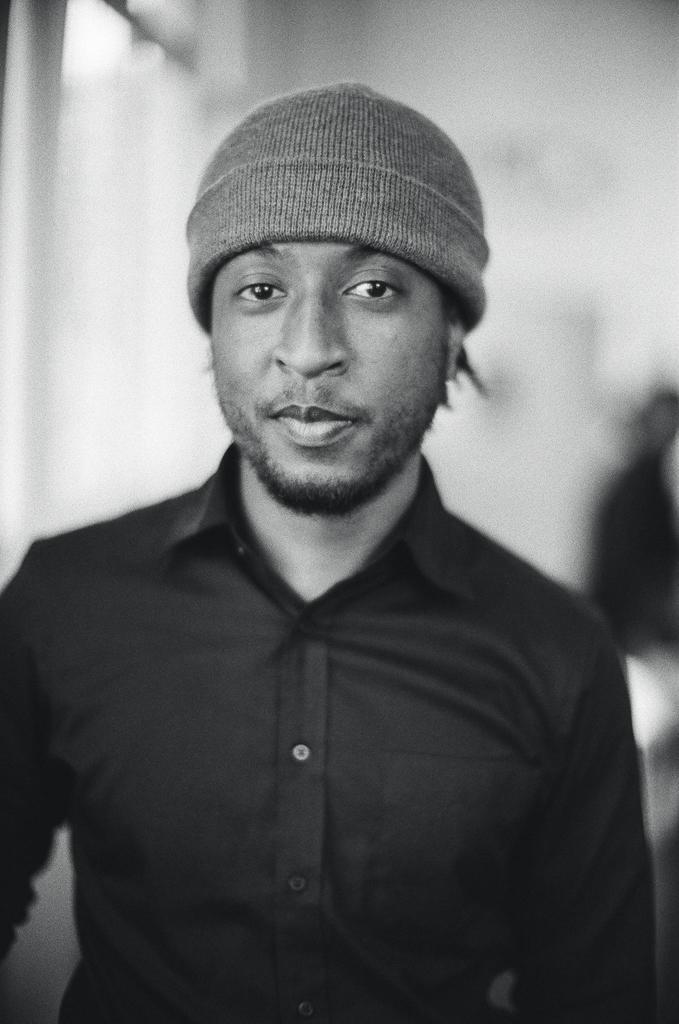What is the main subject of the image? There is a man in the image. What is the man wearing? The man is wearing a black color shirt. What is the man holding in the image? The man is holding a cap. Can you describe the background of the image? There is another person in the background of the image, and there is a white color visible in the background. What type of pan is the monkey using to cook in the image? There is no monkey or pan present in the image. What kind of test is the man taking in the image? There is no indication in the image that the man is taking a test. 